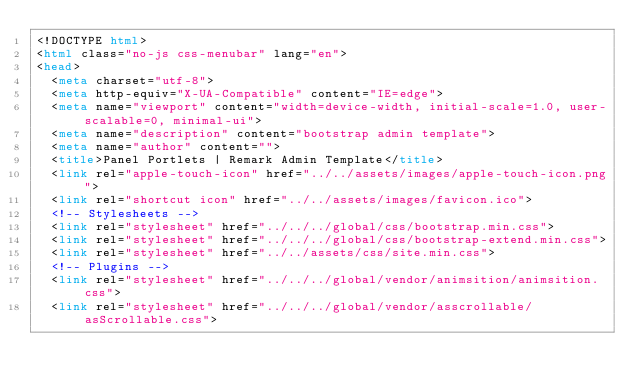<code> <loc_0><loc_0><loc_500><loc_500><_HTML_><!DOCTYPE html>
<html class="no-js css-menubar" lang="en">
<head>
  <meta charset="utf-8">
  <meta http-equiv="X-UA-Compatible" content="IE=edge">
  <meta name="viewport" content="width=device-width, initial-scale=1.0, user-scalable=0, minimal-ui">
  <meta name="description" content="bootstrap admin template">
  <meta name="author" content="">
  <title>Panel Portlets | Remark Admin Template</title>
  <link rel="apple-touch-icon" href="../../assets/images/apple-touch-icon.png">
  <link rel="shortcut icon" href="../../assets/images/favicon.ico">
  <!-- Stylesheets -->
  <link rel="stylesheet" href="../../../global/css/bootstrap.min.css">
  <link rel="stylesheet" href="../../../global/css/bootstrap-extend.min.css">
  <link rel="stylesheet" href="../../assets/css/site.min.css">
  <!-- Plugins -->
  <link rel="stylesheet" href="../../../global/vendor/animsition/animsition.css">
  <link rel="stylesheet" href="../../../global/vendor/asscrollable/asScrollable.css"></code> 